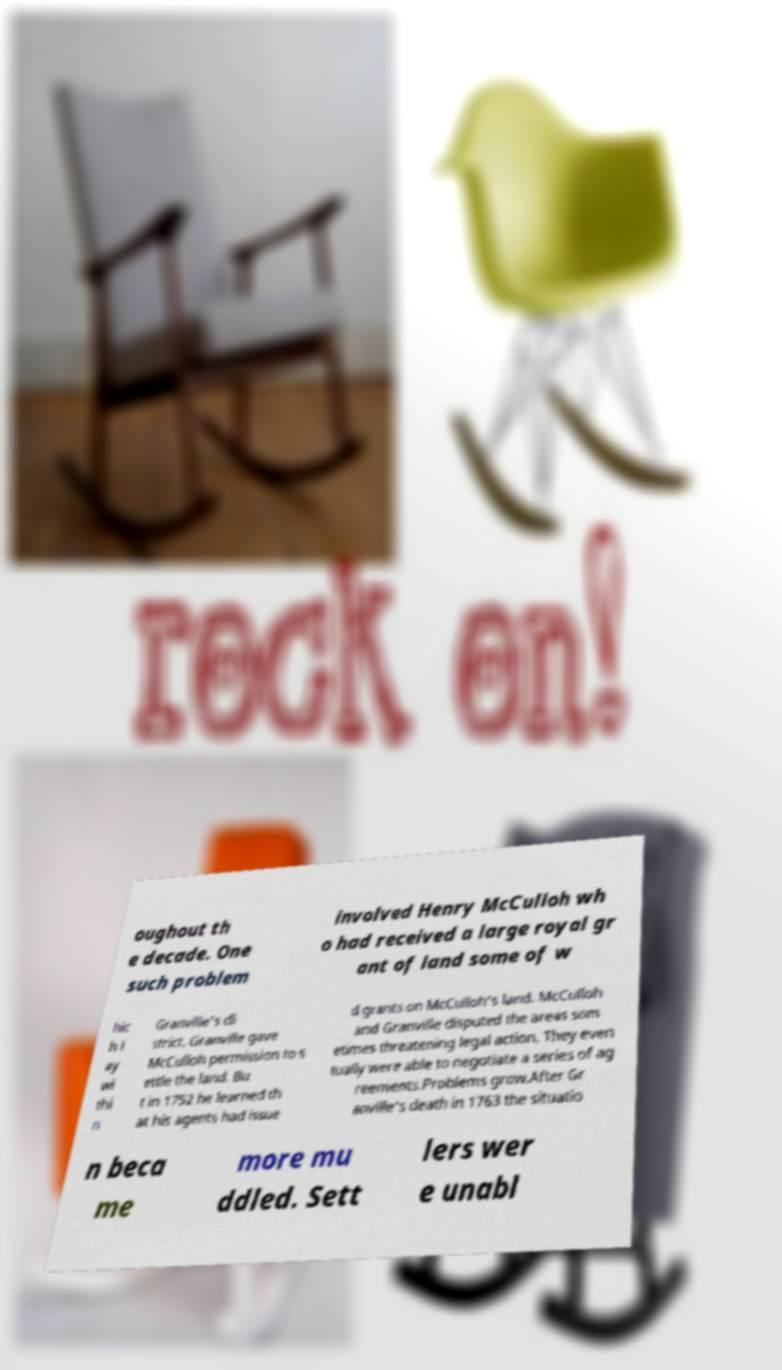There's text embedded in this image that I need extracted. Can you transcribe it verbatim? oughout th e decade. One such problem involved Henry McCulloh wh o had received a large royal gr ant of land some of w hic h l ay wi thi n Granville's di strict. Granville gave McCulloh permission to s ettle the land. Bu t in 1752 he learned th at his agents had issue d grants on McCulloh's land. McCulloh and Granville disputed the areas som etimes threatening legal action. They even tually were able to negotiate a series of ag reements.Problems grow.After Gr anville's death in 1763 the situatio n beca me more mu ddled. Sett lers wer e unabl 